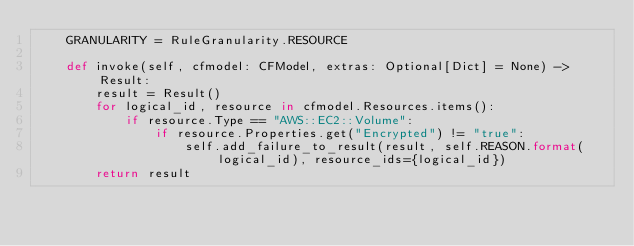Convert code to text. <code><loc_0><loc_0><loc_500><loc_500><_Python_>    GRANULARITY = RuleGranularity.RESOURCE

    def invoke(self, cfmodel: CFModel, extras: Optional[Dict] = None) -> Result:
        result = Result()
        for logical_id, resource in cfmodel.Resources.items():
            if resource.Type == "AWS::EC2::Volume":
                if resource.Properties.get("Encrypted") != "true":
                    self.add_failure_to_result(result, self.REASON.format(logical_id), resource_ids={logical_id})
        return result
</code> 